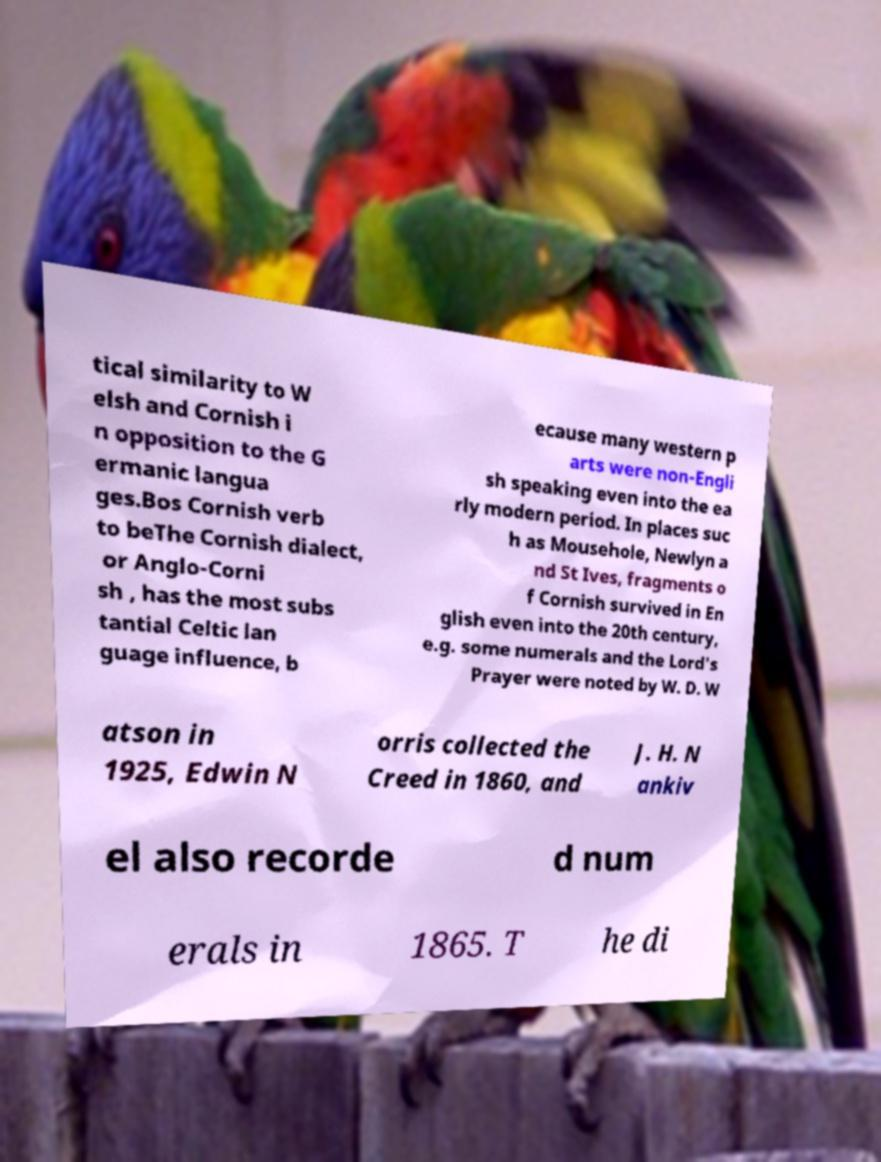Can you accurately transcribe the text from the provided image for me? tical similarity to W elsh and Cornish i n opposition to the G ermanic langua ges.Bos Cornish verb to beThe Cornish dialect, or Anglo-Corni sh , has the most subs tantial Celtic lan guage influence, b ecause many western p arts were non-Engli sh speaking even into the ea rly modern period. In places suc h as Mousehole, Newlyn a nd St Ives, fragments o f Cornish survived in En glish even into the 20th century, e.g. some numerals and the Lord's Prayer were noted by W. D. W atson in 1925, Edwin N orris collected the Creed in 1860, and J. H. N ankiv el also recorde d num erals in 1865. T he di 